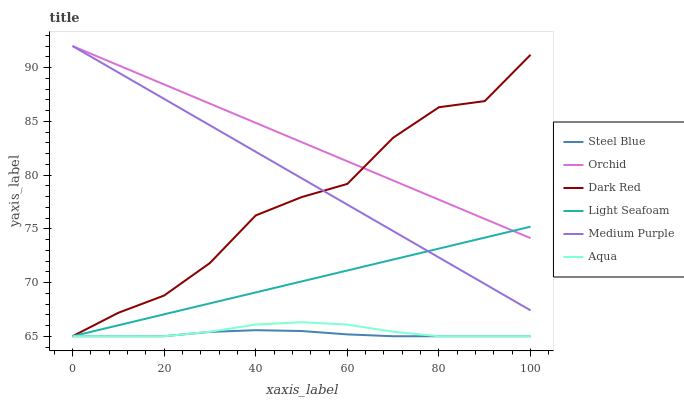Does Steel Blue have the minimum area under the curve?
Answer yes or no. Yes. Does Orchid have the maximum area under the curve?
Answer yes or no. Yes. Does Aqua have the minimum area under the curve?
Answer yes or no. No. Does Aqua have the maximum area under the curve?
Answer yes or no. No. Is Medium Purple the smoothest?
Answer yes or no. Yes. Is Dark Red the roughest?
Answer yes or no. Yes. Is Aqua the smoothest?
Answer yes or no. No. Is Aqua the roughest?
Answer yes or no. No. Does Medium Purple have the lowest value?
Answer yes or no. No. Does Orchid have the highest value?
Answer yes or no. Yes. Does Aqua have the highest value?
Answer yes or no. No. Is Steel Blue less than Orchid?
Answer yes or no. Yes. Is Medium Purple greater than Aqua?
Answer yes or no. Yes. Does Light Seafoam intersect Medium Purple?
Answer yes or no. Yes. Is Light Seafoam less than Medium Purple?
Answer yes or no. No. Is Light Seafoam greater than Medium Purple?
Answer yes or no. No. Does Steel Blue intersect Orchid?
Answer yes or no. No. 